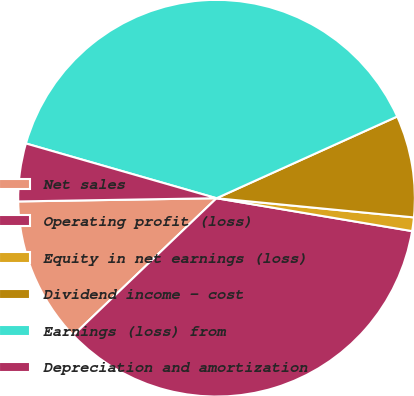Convert chart. <chart><loc_0><loc_0><loc_500><loc_500><pie_chart><fcel>Net sales<fcel>Operating profit (loss)<fcel>Equity in net earnings (loss)<fcel>Dividend income - cost<fcel>Earnings (loss) from<fcel>Depreciation and amortization<nl><fcel>11.89%<fcel>35.2%<fcel>1.11%<fcel>8.3%<fcel>38.79%<fcel>4.71%<nl></chart> 